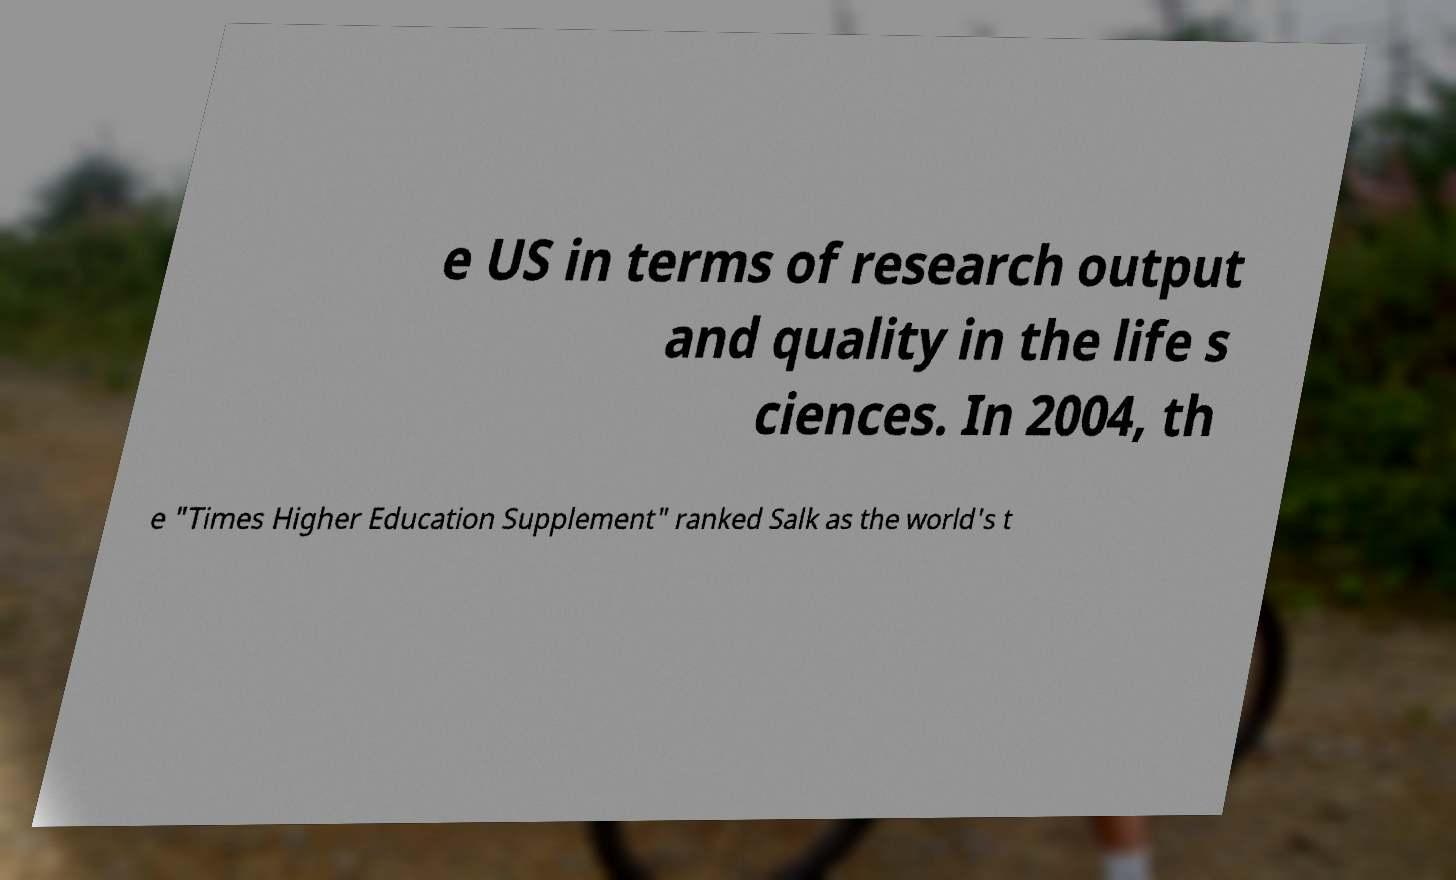Can you read and provide the text displayed in the image?This photo seems to have some interesting text. Can you extract and type it out for me? e US in terms of research output and quality in the life s ciences. In 2004, th e "Times Higher Education Supplement" ranked Salk as the world's t 